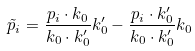<formula> <loc_0><loc_0><loc_500><loc_500>\tilde { p } _ { i } = \frac { p _ { i } \cdot k _ { 0 } } { k _ { 0 } \cdot k ^ { \prime } _ { 0 } } k ^ { \prime } _ { 0 } - \frac { p _ { i } \cdot k ^ { \prime } _ { 0 } } { k _ { 0 } \cdot k ^ { \prime } _ { 0 } } k _ { 0 }</formula> 